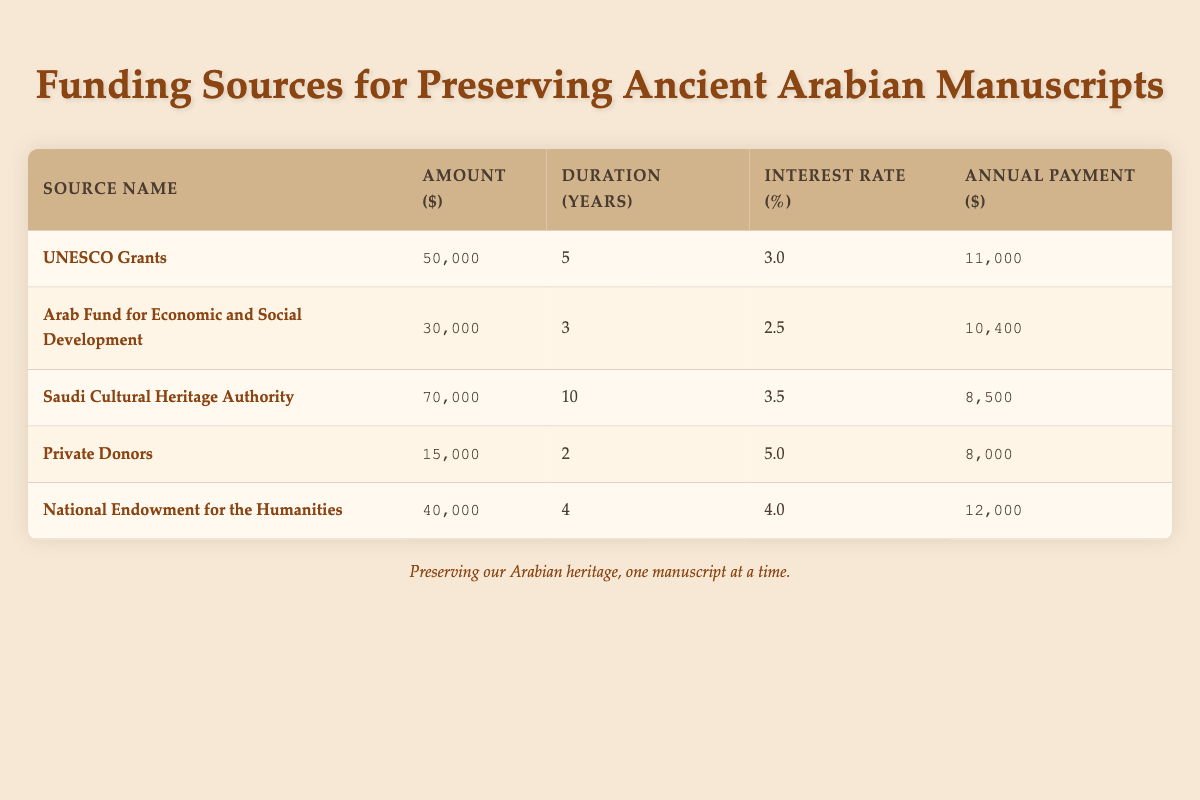What is the total amount of funding sourced from Private Donors? The table shows the funding sources along with their amounts, and for Private Donors, the amount listed is 15,000.
Answer: 15,000 Which funding source has the highest annual payment? By comparing the annual payments listed in the table, UNESCO Grants have the highest annual payment of 11,000.
Answer: UNESCO Grants What is the average interest rate of all funding sources? The interest rates are 3.0, 2.5, 3.5, 5.0, and 4.0. The sum is 18.0, and there are 5 rates. Therefore, the average interest rate is 18.0/5 = 3.6.
Answer: 3.6 Is there a funding source that has an interest rate higher than 4.0? The interest rates listed are 3.0, 2.5, 3.5, 5.0, and 4.0. Since 5.0 is greater than 4.0, the answer is yes.
Answer: Yes What is the total duration in years of all funding sources? By adding the durations from the table: 5 + 3 + 10 + 2 + 4 = 24. Therefore, the total duration is 24 years.
Answer: 24 